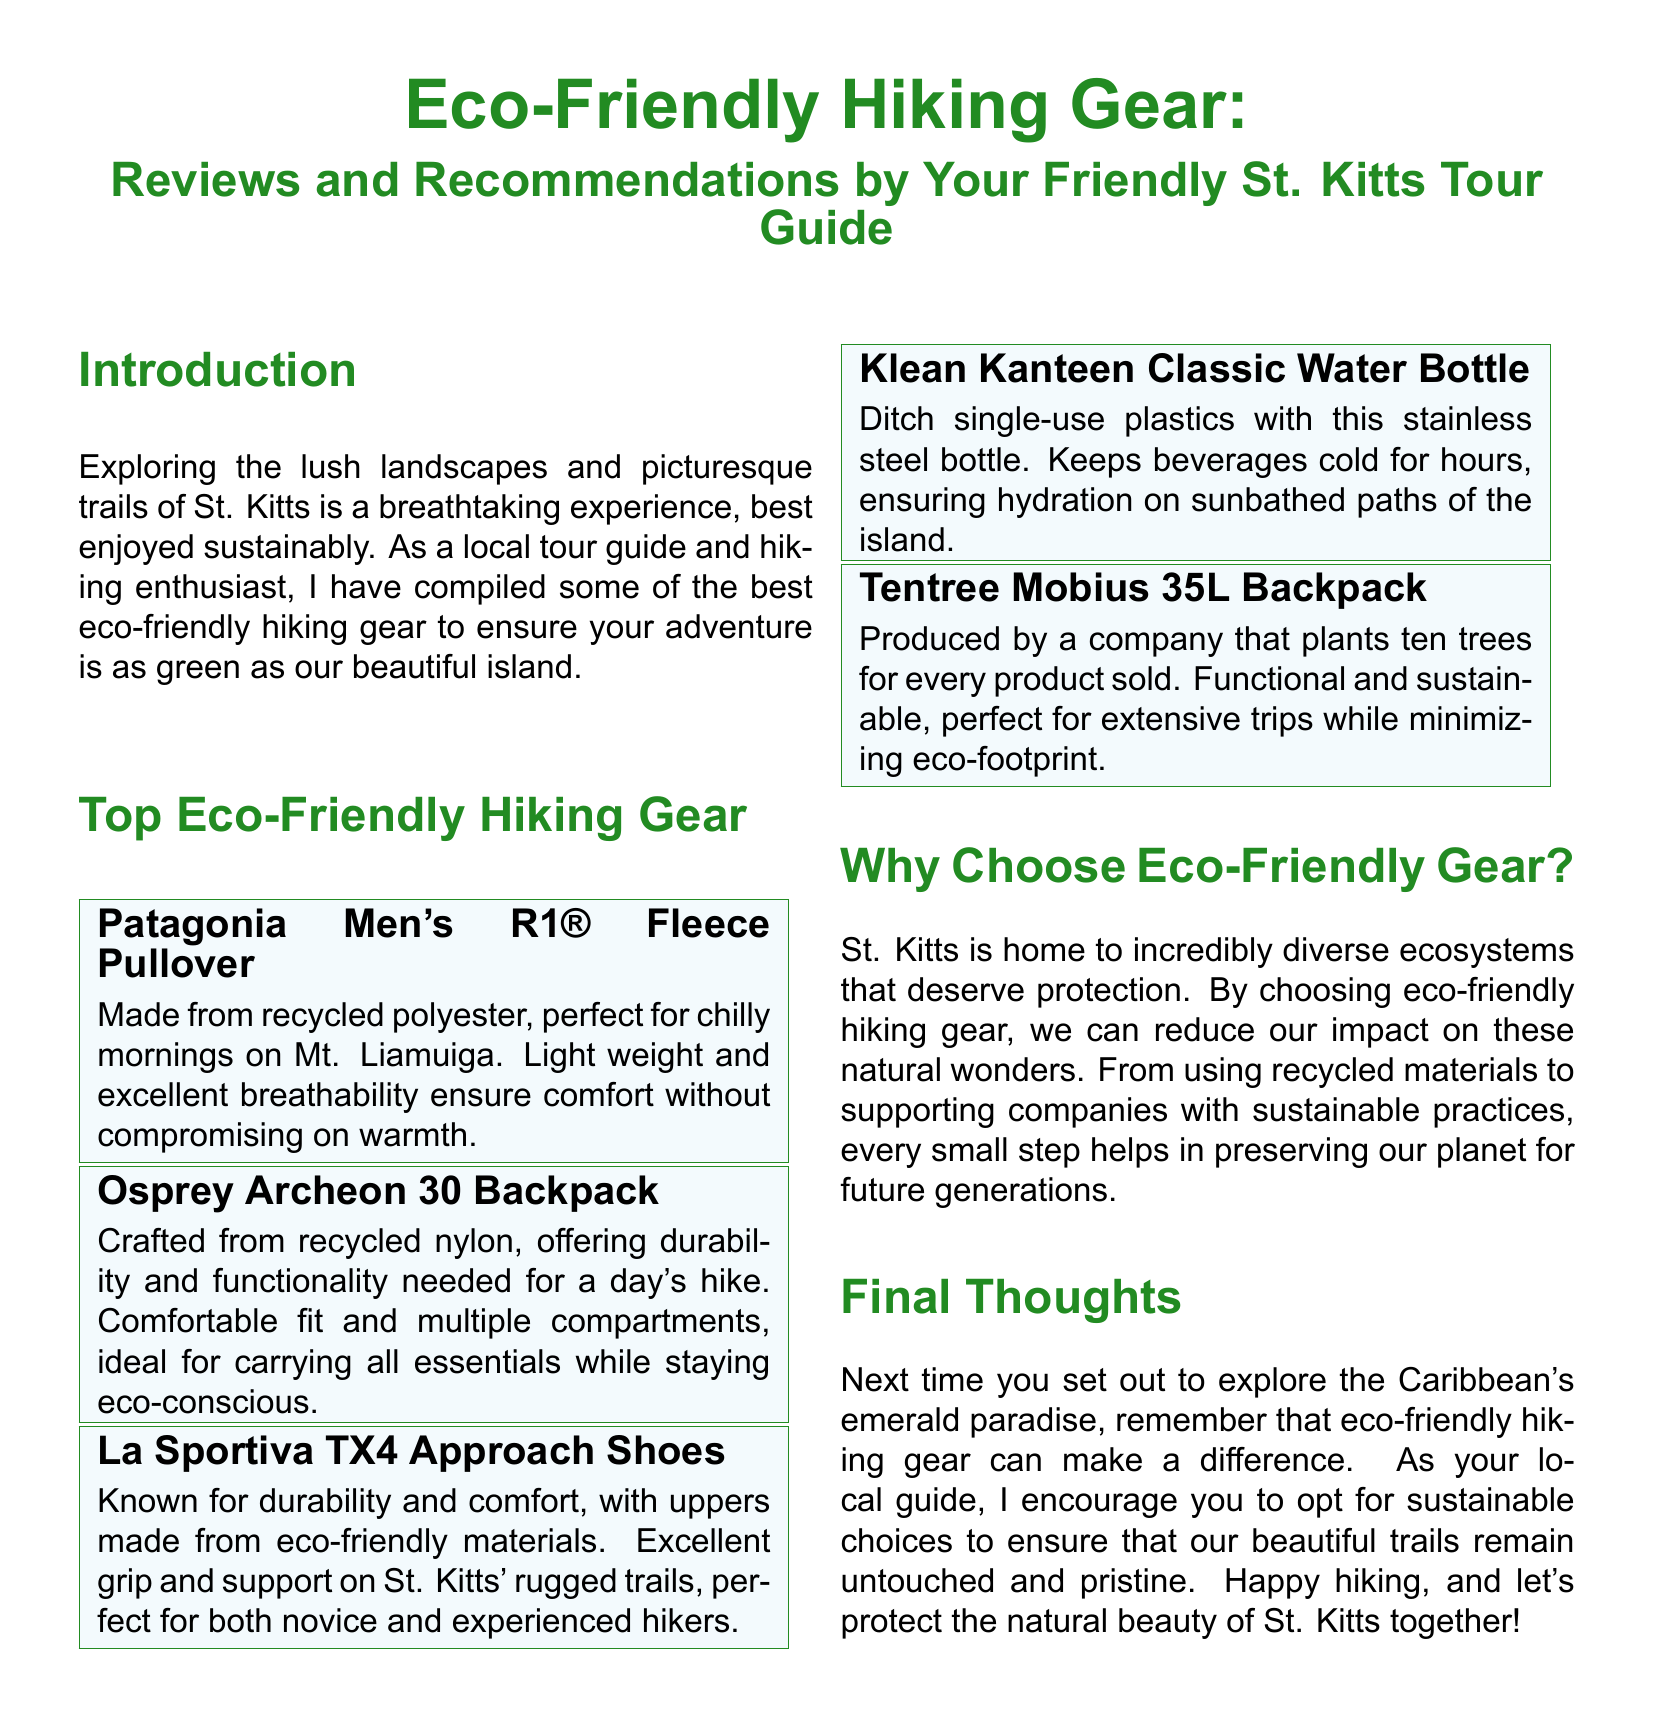What is the title of the document? The title is found at the top of the document, introducing the theme and purpose.
Answer: Eco-Friendly Hiking Gear: Reviews and Recommendations Who is the author of the recommendations? The author is identified in the introduction section as a local tour guide.
Answer: Your Friendly St. Kitts Tour Guide What material is the Patagonia Men's R1® Fleece Pullover made from? The document specifies that it is made from recycled polyester.
Answer: Recycled polyester How many trees does Tentree plant for every product sold? This number is explicitly stated in the description of the Tentree Mobius 35L Backpack.
Answer: Ten trees What is a benefit of the Klean Kanteen Classic Water Bottle? The benefit mentioned is its capability to keep beverages cold for hours.
Answer: Keeps beverages cold for hours Why is it important to choose eco-friendly hiking gear? The reason provided relates to reducing our impact on diverse ecosystems.
Answer: To reduce our impact on ecosystems What type of shoes are the La Sportiva TX4 Approach Shoes known for? The shoes are specifically noted for their durability and comfort.
Answer: Durability and comfort What does the author encourage hikers to do? The author's encouragement is found in the final thoughts section, aimed at promoting sustainability.
Answer: Opt for sustainable choices 